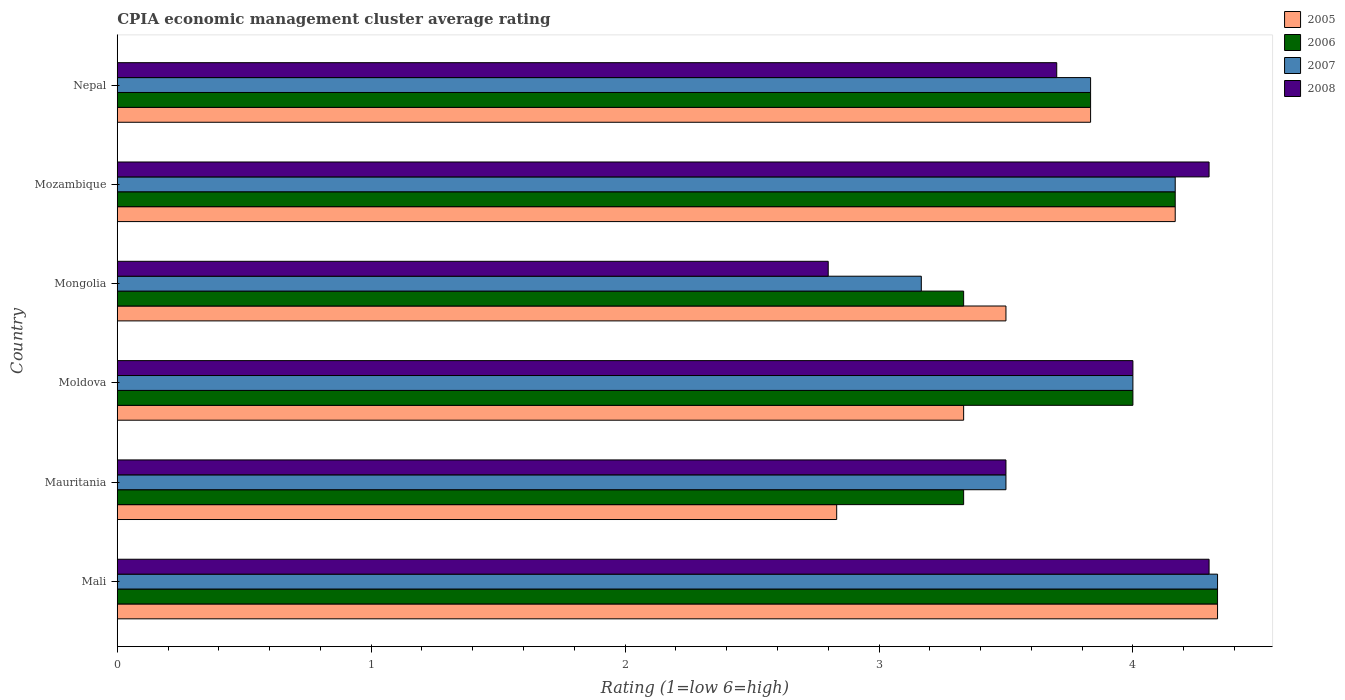How many groups of bars are there?
Your answer should be very brief. 6. Are the number of bars per tick equal to the number of legend labels?
Give a very brief answer. Yes. Are the number of bars on each tick of the Y-axis equal?
Your response must be concise. Yes. How many bars are there on the 1st tick from the top?
Offer a very short reply. 4. What is the label of the 3rd group of bars from the top?
Your response must be concise. Mongolia. In how many cases, is the number of bars for a given country not equal to the number of legend labels?
Provide a short and direct response. 0. What is the CPIA rating in 2005 in Moldova?
Provide a short and direct response. 3.33. Across all countries, what is the maximum CPIA rating in 2007?
Provide a succinct answer. 4.33. In which country was the CPIA rating in 2006 maximum?
Give a very brief answer. Mali. In which country was the CPIA rating in 2006 minimum?
Your answer should be very brief. Mauritania. What is the total CPIA rating in 2005 in the graph?
Your response must be concise. 22. What is the difference between the CPIA rating in 2006 in Moldova and that in Mozambique?
Your answer should be compact. -0.17. What is the difference between the CPIA rating in 2008 in Moldova and the CPIA rating in 2006 in Mongolia?
Keep it short and to the point. 0.67. What is the average CPIA rating in 2006 per country?
Your answer should be very brief. 3.83. In how many countries, is the CPIA rating in 2005 greater than 0.8 ?
Make the answer very short. 6. What is the ratio of the CPIA rating in 2006 in Mali to that in Mongolia?
Provide a short and direct response. 1.3. What is the difference between the highest and the second highest CPIA rating in 2007?
Offer a terse response. 0.17. What is the difference between the highest and the lowest CPIA rating in 2006?
Keep it short and to the point. 1. In how many countries, is the CPIA rating in 2008 greater than the average CPIA rating in 2008 taken over all countries?
Give a very brief answer. 3. Is the sum of the CPIA rating in 2007 in Mongolia and Mozambique greater than the maximum CPIA rating in 2008 across all countries?
Make the answer very short. Yes. Is it the case that in every country, the sum of the CPIA rating in 2005 and CPIA rating in 2007 is greater than the CPIA rating in 2006?
Offer a very short reply. Yes. How many bars are there?
Provide a short and direct response. 24. Are all the bars in the graph horizontal?
Offer a very short reply. Yes. How many countries are there in the graph?
Offer a terse response. 6. What is the difference between two consecutive major ticks on the X-axis?
Give a very brief answer. 1. Does the graph contain any zero values?
Provide a short and direct response. No. Does the graph contain grids?
Ensure brevity in your answer.  No. How many legend labels are there?
Your answer should be very brief. 4. What is the title of the graph?
Your answer should be compact. CPIA economic management cluster average rating. What is the label or title of the X-axis?
Your answer should be very brief. Rating (1=low 6=high). What is the label or title of the Y-axis?
Keep it short and to the point. Country. What is the Rating (1=low 6=high) of 2005 in Mali?
Your response must be concise. 4.33. What is the Rating (1=low 6=high) of 2006 in Mali?
Offer a very short reply. 4.33. What is the Rating (1=low 6=high) of 2007 in Mali?
Provide a succinct answer. 4.33. What is the Rating (1=low 6=high) in 2008 in Mali?
Your response must be concise. 4.3. What is the Rating (1=low 6=high) in 2005 in Mauritania?
Your response must be concise. 2.83. What is the Rating (1=low 6=high) in 2006 in Mauritania?
Provide a short and direct response. 3.33. What is the Rating (1=low 6=high) in 2007 in Mauritania?
Keep it short and to the point. 3.5. What is the Rating (1=low 6=high) in 2005 in Moldova?
Offer a terse response. 3.33. What is the Rating (1=low 6=high) in 2006 in Moldova?
Offer a very short reply. 4. What is the Rating (1=low 6=high) in 2007 in Moldova?
Your response must be concise. 4. What is the Rating (1=low 6=high) in 2008 in Moldova?
Offer a very short reply. 4. What is the Rating (1=low 6=high) of 2005 in Mongolia?
Your answer should be very brief. 3.5. What is the Rating (1=low 6=high) in 2006 in Mongolia?
Offer a terse response. 3.33. What is the Rating (1=low 6=high) of 2007 in Mongolia?
Your answer should be very brief. 3.17. What is the Rating (1=low 6=high) of 2005 in Mozambique?
Your answer should be very brief. 4.17. What is the Rating (1=low 6=high) of 2006 in Mozambique?
Give a very brief answer. 4.17. What is the Rating (1=low 6=high) of 2007 in Mozambique?
Your answer should be compact. 4.17. What is the Rating (1=low 6=high) of 2005 in Nepal?
Your answer should be very brief. 3.83. What is the Rating (1=low 6=high) in 2006 in Nepal?
Your response must be concise. 3.83. What is the Rating (1=low 6=high) of 2007 in Nepal?
Make the answer very short. 3.83. What is the Rating (1=low 6=high) in 2008 in Nepal?
Ensure brevity in your answer.  3.7. Across all countries, what is the maximum Rating (1=low 6=high) in 2005?
Provide a short and direct response. 4.33. Across all countries, what is the maximum Rating (1=low 6=high) in 2006?
Your response must be concise. 4.33. Across all countries, what is the maximum Rating (1=low 6=high) of 2007?
Offer a terse response. 4.33. Across all countries, what is the maximum Rating (1=low 6=high) of 2008?
Your answer should be very brief. 4.3. Across all countries, what is the minimum Rating (1=low 6=high) in 2005?
Your answer should be compact. 2.83. Across all countries, what is the minimum Rating (1=low 6=high) in 2006?
Your response must be concise. 3.33. Across all countries, what is the minimum Rating (1=low 6=high) of 2007?
Your answer should be very brief. 3.17. What is the total Rating (1=low 6=high) in 2006 in the graph?
Make the answer very short. 23. What is the total Rating (1=low 6=high) of 2008 in the graph?
Your answer should be compact. 22.6. What is the difference between the Rating (1=low 6=high) of 2005 in Mali and that in Mozambique?
Your answer should be very brief. 0.17. What is the difference between the Rating (1=low 6=high) of 2005 in Mali and that in Nepal?
Make the answer very short. 0.5. What is the difference between the Rating (1=low 6=high) in 2007 in Mali and that in Nepal?
Make the answer very short. 0.5. What is the difference between the Rating (1=low 6=high) of 2008 in Mali and that in Nepal?
Offer a very short reply. 0.6. What is the difference between the Rating (1=low 6=high) in 2005 in Mauritania and that in Moldova?
Your answer should be compact. -0.5. What is the difference between the Rating (1=low 6=high) of 2008 in Mauritania and that in Moldova?
Ensure brevity in your answer.  -0.5. What is the difference between the Rating (1=low 6=high) in 2005 in Mauritania and that in Mongolia?
Provide a short and direct response. -0.67. What is the difference between the Rating (1=low 6=high) in 2006 in Mauritania and that in Mongolia?
Ensure brevity in your answer.  0. What is the difference between the Rating (1=low 6=high) in 2007 in Mauritania and that in Mongolia?
Your answer should be very brief. 0.33. What is the difference between the Rating (1=low 6=high) in 2005 in Mauritania and that in Mozambique?
Your response must be concise. -1.33. What is the difference between the Rating (1=low 6=high) of 2008 in Mauritania and that in Mozambique?
Offer a very short reply. -0.8. What is the difference between the Rating (1=low 6=high) in 2007 in Mauritania and that in Nepal?
Your answer should be compact. -0.33. What is the difference between the Rating (1=low 6=high) of 2008 in Mauritania and that in Nepal?
Your response must be concise. -0.2. What is the difference between the Rating (1=low 6=high) of 2005 in Moldova and that in Mongolia?
Your answer should be compact. -0.17. What is the difference between the Rating (1=low 6=high) in 2008 in Moldova and that in Mongolia?
Offer a terse response. 1.2. What is the difference between the Rating (1=low 6=high) of 2007 in Moldova and that in Mozambique?
Ensure brevity in your answer.  -0.17. What is the difference between the Rating (1=low 6=high) in 2008 in Moldova and that in Mozambique?
Your response must be concise. -0.3. What is the difference between the Rating (1=low 6=high) of 2005 in Moldova and that in Nepal?
Ensure brevity in your answer.  -0.5. What is the difference between the Rating (1=low 6=high) in 2006 in Moldova and that in Nepal?
Offer a very short reply. 0.17. What is the difference between the Rating (1=low 6=high) in 2008 in Moldova and that in Nepal?
Give a very brief answer. 0.3. What is the difference between the Rating (1=low 6=high) in 2005 in Mongolia and that in Mozambique?
Offer a terse response. -0.67. What is the difference between the Rating (1=low 6=high) of 2006 in Mongolia and that in Mozambique?
Provide a succinct answer. -0.83. What is the difference between the Rating (1=low 6=high) in 2007 in Mongolia and that in Mozambique?
Offer a terse response. -1. What is the difference between the Rating (1=low 6=high) of 2008 in Mongolia and that in Nepal?
Your response must be concise. -0.9. What is the difference between the Rating (1=low 6=high) in 2007 in Mozambique and that in Nepal?
Your response must be concise. 0.33. What is the difference between the Rating (1=low 6=high) of 2005 in Mali and the Rating (1=low 6=high) of 2006 in Mauritania?
Make the answer very short. 1. What is the difference between the Rating (1=low 6=high) of 2005 in Mali and the Rating (1=low 6=high) of 2007 in Mauritania?
Provide a succinct answer. 0.83. What is the difference between the Rating (1=low 6=high) in 2006 in Mali and the Rating (1=low 6=high) in 2007 in Mauritania?
Your answer should be very brief. 0.83. What is the difference between the Rating (1=low 6=high) of 2006 in Mali and the Rating (1=low 6=high) of 2008 in Mauritania?
Provide a short and direct response. 0.83. What is the difference between the Rating (1=low 6=high) of 2005 in Mali and the Rating (1=low 6=high) of 2007 in Moldova?
Offer a terse response. 0.33. What is the difference between the Rating (1=low 6=high) of 2005 in Mali and the Rating (1=low 6=high) of 2008 in Moldova?
Your answer should be compact. 0.33. What is the difference between the Rating (1=low 6=high) in 2006 in Mali and the Rating (1=low 6=high) in 2007 in Moldova?
Provide a succinct answer. 0.33. What is the difference between the Rating (1=low 6=high) in 2006 in Mali and the Rating (1=low 6=high) in 2008 in Moldova?
Make the answer very short. 0.33. What is the difference between the Rating (1=low 6=high) in 2007 in Mali and the Rating (1=low 6=high) in 2008 in Moldova?
Keep it short and to the point. 0.33. What is the difference between the Rating (1=low 6=high) in 2005 in Mali and the Rating (1=low 6=high) in 2006 in Mongolia?
Give a very brief answer. 1. What is the difference between the Rating (1=low 6=high) in 2005 in Mali and the Rating (1=low 6=high) in 2008 in Mongolia?
Your answer should be very brief. 1.53. What is the difference between the Rating (1=low 6=high) of 2006 in Mali and the Rating (1=low 6=high) of 2007 in Mongolia?
Offer a terse response. 1.17. What is the difference between the Rating (1=low 6=high) of 2006 in Mali and the Rating (1=low 6=high) of 2008 in Mongolia?
Make the answer very short. 1.53. What is the difference between the Rating (1=low 6=high) of 2007 in Mali and the Rating (1=low 6=high) of 2008 in Mongolia?
Provide a short and direct response. 1.53. What is the difference between the Rating (1=low 6=high) of 2005 in Mali and the Rating (1=low 6=high) of 2007 in Mozambique?
Your response must be concise. 0.17. What is the difference between the Rating (1=low 6=high) of 2006 in Mali and the Rating (1=low 6=high) of 2007 in Mozambique?
Ensure brevity in your answer.  0.17. What is the difference between the Rating (1=low 6=high) of 2006 in Mali and the Rating (1=low 6=high) of 2008 in Mozambique?
Make the answer very short. 0.03. What is the difference between the Rating (1=low 6=high) of 2007 in Mali and the Rating (1=low 6=high) of 2008 in Mozambique?
Your answer should be very brief. 0.03. What is the difference between the Rating (1=low 6=high) in 2005 in Mali and the Rating (1=low 6=high) in 2007 in Nepal?
Provide a succinct answer. 0.5. What is the difference between the Rating (1=low 6=high) of 2005 in Mali and the Rating (1=low 6=high) of 2008 in Nepal?
Your answer should be very brief. 0.63. What is the difference between the Rating (1=low 6=high) in 2006 in Mali and the Rating (1=low 6=high) in 2008 in Nepal?
Provide a succinct answer. 0.63. What is the difference between the Rating (1=low 6=high) in 2007 in Mali and the Rating (1=low 6=high) in 2008 in Nepal?
Offer a terse response. 0.63. What is the difference between the Rating (1=low 6=high) of 2005 in Mauritania and the Rating (1=low 6=high) of 2006 in Moldova?
Offer a very short reply. -1.17. What is the difference between the Rating (1=low 6=high) of 2005 in Mauritania and the Rating (1=low 6=high) of 2007 in Moldova?
Offer a very short reply. -1.17. What is the difference between the Rating (1=low 6=high) of 2005 in Mauritania and the Rating (1=low 6=high) of 2008 in Moldova?
Make the answer very short. -1.17. What is the difference between the Rating (1=low 6=high) in 2007 in Mauritania and the Rating (1=low 6=high) in 2008 in Moldova?
Keep it short and to the point. -0.5. What is the difference between the Rating (1=low 6=high) in 2005 in Mauritania and the Rating (1=low 6=high) in 2006 in Mongolia?
Ensure brevity in your answer.  -0.5. What is the difference between the Rating (1=low 6=high) of 2006 in Mauritania and the Rating (1=low 6=high) of 2008 in Mongolia?
Provide a succinct answer. 0.53. What is the difference between the Rating (1=low 6=high) of 2007 in Mauritania and the Rating (1=low 6=high) of 2008 in Mongolia?
Your answer should be very brief. 0.7. What is the difference between the Rating (1=low 6=high) of 2005 in Mauritania and the Rating (1=low 6=high) of 2006 in Mozambique?
Ensure brevity in your answer.  -1.33. What is the difference between the Rating (1=low 6=high) of 2005 in Mauritania and the Rating (1=low 6=high) of 2007 in Mozambique?
Your answer should be very brief. -1.33. What is the difference between the Rating (1=low 6=high) in 2005 in Mauritania and the Rating (1=low 6=high) in 2008 in Mozambique?
Provide a short and direct response. -1.47. What is the difference between the Rating (1=low 6=high) of 2006 in Mauritania and the Rating (1=low 6=high) of 2007 in Mozambique?
Your response must be concise. -0.83. What is the difference between the Rating (1=low 6=high) of 2006 in Mauritania and the Rating (1=low 6=high) of 2008 in Mozambique?
Make the answer very short. -0.97. What is the difference between the Rating (1=low 6=high) of 2005 in Mauritania and the Rating (1=low 6=high) of 2006 in Nepal?
Ensure brevity in your answer.  -1. What is the difference between the Rating (1=low 6=high) in 2005 in Mauritania and the Rating (1=low 6=high) in 2007 in Nepal?
Make the answer very short. -1. What is the difference between the Rating (1=low 6=high) of 2005 in Mauritania and the Rating (1=low 6=high) of 2008 in Nepal?
Provide a short and direct response. -0.87. What is the difference between the Rating (1=low 6=high) in 2006 in Mauritania and the Rating (1=low 6=high) in 2008 in Nepal?
Ensure brevity in your answer.  -0.37. What is the difference between the Rating (1=low 6=high) in 2007 in Mauritania and the Rating (1=low 6=high) in 2008 in Nepal?
Keep it short and to the point. -0.2. What is the difference between the Rating (1=low 6=high) of 2005 in Moldova and the Rating (1=low 6=high) of 2006 in Mongolia?
Your answer should be very brief. 0. What is the difference between the Rating (1=low 6=high) of 2005 in Moldova and the Rating (1=low 6=high) of 2008 in Mongolia?
Ensure brevity in your answer.  0.53. What is the difference between the Rating (1=low 6=high) in 2006 in Moldova and the Rating (1=low 6=high) in 2007 in Mongolia?
Ensure brevity in your answer.  0.83. What is the difference between the Rating (1=low 6=high) of 2006 in Moldova and the Rating (1=low 6=high) of 2008 in Mongolia?
Offer a very short reply. 1.2. What is the difference between the Rating (1=low 6=high) of 2005 in Moldova and the Rating (1=low 6=high) of 2007 in Mozambique?
Ensure brevity in your answer.  -0.83. What is the difference between the Rating (1=low 6=high) in 2005 in Moldova and the Rating (1=low 6=high) in 2008 in Mozambique?
Give a very brief answer. -0.97. What is the difference between the Rating (1=low 6=high) of 2006 in Moldova and the Rating (1=low 6=high) of 2008 in Mozambique?
Make the answer very short. -0.3. What is the difference between the Rating (1=low 6=high) in 2007 in Moldova and the Rating (1=low 6=high) in 2008 in Mozambique?
Your answer should be very brief. -0.3. What is the difference between the Rating (1=low 6=high) in 2005 in Moldova and the Rating (1=low 6=high) in 2007 in Nepal?
Your answer should be compact. -0.5. What is the difference between the Rating (1=low 6=high) of 2005 in Moldova and the Rating (1=low 6=high) of 2008 in Nepal?
Your response must be concise. -0.37. What is the difference between the Rating (1=low 6=high) of 2006 in Moldova and the Rating (1=low 6=high) of 2008 in Nepal?
Offer a terse response. 0.3. What is the difference between the Rating (1=low 6=high) of 2005 in Mongolia and the Rating (1=low 6=high) of 2006 in Mozambique?
Make the answer very short. -0.67. What is the difference between the Rating (1=low 6=high) of 2006 in Mongolia and the Rating (1=low 6=high) of 2007 in Mozambique?
Ensure brevity in your answer.  -0.83. What is the difference between the Rating (1=low 6=high) in 2006 in Mongolia and the Rating (1=low 6=high) in 2008 in Mozambique?
Your answer should be very brief. -0.97. What is the difference between the Rating (1=low 6=high) in 2007 in Mongolia and the Rating (1=low 6=high) in 2008 in Mozambique?
Offer a terse response. -1.13. What is the difference between the Rating (1=low 6=high) in 2005 in Mongolia and the Rating (1=low 6=high) in 2008 in Nepal?
Keep it short and to the point. -0.2. What is the difference between the Rating (1=low 6=high) of 2006 in Mongolia and the Rating (1=low 6=high) of 2007 in Nepal?
Make the answer very short. -0.5. What is the difference between the Rating (1=low 6=high) of 2006 in Mongolia and the Rating (1=low 6=high) of 2008 in Nepal?
Offer a very short reply. -0.37. What is the difference between the Rating (1=low 6=high) of 2007 in Mongolia and the Rating (1=low 6=high) of 2008 in Nepal?
Your answer should be very brief. -0.53. What is the difference between the Rating (1=low 6=high) of 2005 in Mozambique and the Rating (1=low 6=high) of 2006 in Nepal?
Your answer should be very brief. 0.33. What is the difference between the Rating (1=low 6=high) in 2005 in Mozambique and the Rating (1=low 6=high) in 2008 in Nepal?
Ensure brevity in your answer.  0.47. What is the difference between the Rating (1=low 6=high) of 2006 in Mozambique and the Rating (1=low 6=high) of 2007 in Nepal?
Ensure brevity in your answer.  0.33. What is the difference between the Rating (1=low 6=high) in 2006 in Mozambique and the Rating (1=low 6=high) in 2008 in Nepal?
Provide a short and direct response. 0.47. What is the difference between the Rating (1=low 6=high) in 2007 in Mozambique and the Rating (1=low 6=high) in 2008 in Nepal?
Ensure brevity in your answer.  0.47. What is the average Rating (1=low 6=high) in 2005 per country?
Keep it short and to the point. 3.67. What is the average Rating (1=low 6=high) of 2006 per country?
Offer a very short reply. 3.83. What is the average Rating (1=low 6=high) of 2007 per country?
Your answer should be compact. 3.83. What is the average Rating (1=low 6=high) in 2008 per country?
Your answer should be very brief. 3.77. What is the difference between the Rating (1=low 6=high) in 2005 and Rating (1=low 6=high) in 2006 in Mali?
Offer a terse response. 0. What is the difference between the Rating (1=low 6=high) of 2005 and Rating (1=low 6=high) of 2008 in Mali?
Keep it short and to the point. 0.03. What is the difference between the Rating (1=low 6=high) of 2006 and Rating (1=low 6=high) of 2008 in Mali?
Offer a very short reply. 0.03. What is the difference between the Rating (1=low 6=high) of 2007 and Rating (1=low 6=high) of 2008 in Mali?
Provide a short and direct response. 0.03. What is the difference between the Rating (1=low 6=high) of 2005 and Rating (1=low 6=high) of 2006 in Mauritania?
Provide a succinct answer. -0.5. What is the difference between the Rating (1=low 6=high) in 2005 and Rating (1=low 6=high) in 2008 in Mauritania?
Give a very brief answer. -0.67. What is the difference between the Rating (1=low 6=high) in 2007 and Rating (1=low 6=high) in 2008 in Mauritania?
Provide a succinct answer. 0. What is the difference between the Rating (1=low 6=high) of 2005 and Rating (1=low 6=high) of 2006 in Moldova?
Offer a very short reply. -0.67. What is the difference between the Rating (1=low 6=high) in 2005 and Rating (1=low 6=high) in 2008 in Moldova?
Your response must be concise. -0.67. What is the difference between the Rating (1=low 6=high) in 2006 and Rating (1=low 6=high) in 2007 in Moldova?
Make the answer very short. 0. What is the difference between the Rating (1=low 6=high) of 2006 and Rating (1=low 6=high) of 2008 in Moldova?
Your response must be concise. 0. What is the difference between the Rating (1=low 6=high) in 2007 and Rating (1=low 6=high) in 2008 in Moldova?
Your answer should be very brief. 0. What is the difference between the Rating (1=low 6=high) in 2005 and Rating (1=low 6=high) in 2008 in Mongolia?
Offer a terse response. 0.7. What is the difference between the Rating (1=low 6=high) of 2006 and Rating (1=low 6=high) of 2008 in Mongolia?
Ensure brevity in your answer.  0.53. What is the difference between the Rating (1=low 6=high) of 2007 and Rating (1=low 6=high) of 2008 in Mongolia?
Give a very brief answer. 0.37. What is the difference between the Rating (1=low 6=high) in 2005 and Rating (1=low 6=high) in 2006 in Mozambique?
Provide a succinct answer. 0. What is the difference between the Rating (1=low 6=high) of 2005 and Rating (1=low 6=high) of 2007 in Mozambique?
Your answer should be very brief. 0. What is the difference between the Rating (1=low 6=high) of 2005 and Rating (1=low 6=high) of 2008 in Mozambique?
Your response must be concise. -0.13. What is the difference between the Rating (1=low 6=high) in 2006 and Rating (1=low 6=high) in 2008 in Mozambique?
Your response must be concise. -0.13. What is the difference between the Rating (1=low 6=high) of 2007 and Rating (1=low 6=high) of 2008 in Mozambique?
Offer a terse response. -0.13. What is the difference between the Rating (1=low 6=high) in 2005 and Rating (1=low 6=high) in 2006 in Nepal?
Your answer should be very brief. 0. What is the difference between the Rating (1=low 6=high) in 2005 and Rating (1=low 6=high) in 2007 in Nepal?
Your answer should be compact. 0. What is the difference between the Rating (1=low 6=high) of 2005 and Rating (1=low 6=high) of 2008 in Nepal?
Your answer should be very brief. 0.13. What is the difference between the Rating (1=low 6=high) of 2006 and Rating (1=low 6=high) of 2007 in Nepal?
Your answer should be compact. 0. What is the difference between the Rating (1=low 6=high) in 2006 and Rating (1=low 6=high) in 2008 in Nepal?
Give a very brief answer. 0.13. What is the difference between the Rating (1=low 6=high) in 2007 and Rating (1=low 6=high) in 2008 in Nepal?
Make the answer very short. 0.13. What is the ratio of the Rating (1=low 6=high) of 2005 in Mali to that in Mauritania?
Your answer should be compact. 1.53. What is the ratio of the Rating (1=low 6=high) in 2007 in Mali to that in Mauritania?
Make the answer very short. 1.24. What is the ratio of the Rating (1=low 6=high) of 2008 in Mali to that in Mauritania?
Offer a very short reply. 1.23. What is the ratio of the Rating (1=low 6=high) of 2005 in Mali to that in Moldova?
Offer a very short reply. 1.3. What is the ratio of the Rating (1=low 6=high) of 2006 in Mali to that in Moldova?
Make the answer very short. 1.08. What is the ratio of the Rating (1=low 6=high) in 2007 in Mali to that in Moldova?
Keep it short and to the point. 1.08. What is the ratio of the Rating (1=low 6=high) in 2008 in Mali to that in Moldova?
Keep it short and to the point. 1.07. What is the ratio of the Rating (1=low 6=high) of 2005 in Mali to that in Mongolia?
Your answer should be compact. 1.24. What is the ratio of the Rating (1=low 6=high) in 2006 in Mali to that in Mongolia?
Give a very brief answer. 1.3. What is the ratio of the Rating (1=low 6=high) of 2007 in Mali to that in Mongolia?
Your answer should be compact. 1.37. What is the ratio of the Rating (1=low 6=high) in 2008 in Mali to that in Mongolia?
Your response must be concise. 1.54. What is the ratio of the Rating (1=low 6=high) of 2007 in Mali to that in Mozambique?
Offer a very short reply. 1.04. What is the ratio of the Rating (1=low 6=high) of 2005 in Mali to that in Nepal?
Your response must be concise. 1.13. What is the ratio of the Rating (1=low 6=high) in 2006 in Mali to that in Nepal?
Your answer should be compact. 1.13. What is the ratio of the Rating (1=low 6=high) of 2007 in Mali to that in Nepal?
Ensure brevity in your answer.  1.13. What is the ratio of the Rating (1=low 6=high) of 2008 in Mali to that in Nepal?
Make the answer very short. 1.16. What is the ratio of the Rating (1=low 6=high) in 2005 in Mauritania to that in Mongolia?
Make the answer very short. 0.81. What is the ratio of the Rating (1=low 6=high) of 2007 in Mauritania to that in Mongolia?
Provide a succinct answer. 1.11. What is the ratio of the Rating (1=low 6=high) in 2008 in Mauritania to that in Mongolia?
Offer a terse response. 1.25. What is the ratio of the Rating (1=low 6=high) in 2005 in Mauritania to that in Mozambique?
Ensure brevity in your answer.  0.68. What is the ratio of the Rating (1=low 6=high) of 2006 in Mauritania to that in Mozambique?
Offer a very short reply. 0.8. What is the ratio of the Rating (1=low 6=high) of 2007 in Mauritania to that in Mozambique?
Keep it short and to the point. 0.84. What is the ratio of the Rating (1=low 6=high) of 2008 in Mauritania to that in Mozambique?
Your answer should be very brief. 0.81. What is the ratio of the Rating (1=low 6=high) of 2005 in Mauritania to that in Nepal?
Your answer should be compact. 0.74. What is the ratio of the Rating (1=low 6=high) of 2006 in Mauritania to that in Nepal?
Make the answer very short. 0.87. What is the ratio of the Rating (1=low 6=high) in 2008 in Mauritania to that in Nepal?
Give a very brief answer. 0.95. What is the ratio of the Rating (1=low 6=high) in 2005 in Moldova to that in Mongolia?
Ensure brevity in your answer.  0.95. What is the ratio of the Rating (1=low 6=high) of 2006 in Moldova to that in Mongolia?
Your answer should be compact. 1.2. What is the ratio of the Rating (1=low 6=high) in 2007 in Moldova to that in Mongolia?
Offer a very short reply. 1.26. What is the ratio of the Rating (1=low 6=high) in 2008 in Moldova to that in Mongolia?
Keep it short and to the point. 1.43. What is the ratio of the Rating (1=low 6=high) in 2007 in Moldova to that in Mozambique?
Provide a succinct answer. 0.96. What is the ratio of the Rating (1=low 6=high) of 2008 in Moldova to that in Mozambique?
Your answer should be very brief. 0.93. What is the ratio of the Rating (1=low 6=high) in 2005 in Moldova to that in Nepal?
Keep it short and to the point. 0.87. What is the ratio of the Rating (1=low 6=high) of 2006 in Moldova to that in Nepal?
Your response must be concise. 1.04. What is the ratio of the Rating (1=low 6=high) in 2007 in Moldova to that in Nepal?
Your answer should be compact. 1.04. What is the ratio of the Rating (1=low 6=high) in 2008 in Moldova to that in Nepal?
Offer a terse response. 1.08. What is the ratio of the Rating (1=low 6=high) of 2005 in Mongolia to that in Mozambique?
Make the answer very short. 0.84. What is the ratio of the Rating (1=low 6=high) in 2006 in Mongolia to that in Mozambique?
Offer a terse response. 0.8. What is the ratio of the Rating (1=low 6=high) of 2007 in Mongolia to that in Mozambique?
Your answer should be very brief. 0.76. What is the ratio of the Rating (1=low 6=high) in 2008 in Mongolia to that in Mozambique?
Make the answer very short. 0.65. What is the ratio of the Rating (1=low 6=high) of 2005 in Mongolia to that in Nepal?
Give a very brief answer. 0.91. What is the ratio of the Rating (1=low 6=high) in 2006 in Mongolia to that in Nepal?
Provide a succinct answer. 0.87. What is the ratio of the Rating (1=low 6=high) of 2007 in Mongolia to that in Nepal?
Keep it short and to the point. 0.83. What is the ratio of the Rating (1=low 6=high) in 2008 in Mongolia to that in Nepal?
Offer a terse response. 0.76. What is the ratio of the Rating (1=low 6=high) in 2005 in Mozambique to that in Nepal?
Offer a very short reply. 1.09. What is the ratio of the Rating (1=low 6=high) in 2006 in Mozambique to that in Nepal?
Make the answer very short. 1.09. What is the ratio of the Rating (1=low 6=high) in 2007 in Mozambique to that in Nepal?
Offer a terse response. 1.09. What is the ratio of the Rating (1=low 6=high) of 2008 in Mozambique to that in Nepal?
Offer a terse response. 1.16. What is the difference between the highest and the second highest Rating (1=low 6=high) of 2006?
Offer a very short reply. 0.17. What is the difference between the highest and the second highest Rating (1=low 6=high) in 2008?
Offer a terse response. 0. What is the difference between the highest and the lowest Rating (1=low 6=high) of 2006?
Your answer should be very brief. 1. What is the difference between the highest and the lowest Rating (1=low 6=high) of 2007?
Provide a short and direct response. 1.17. 